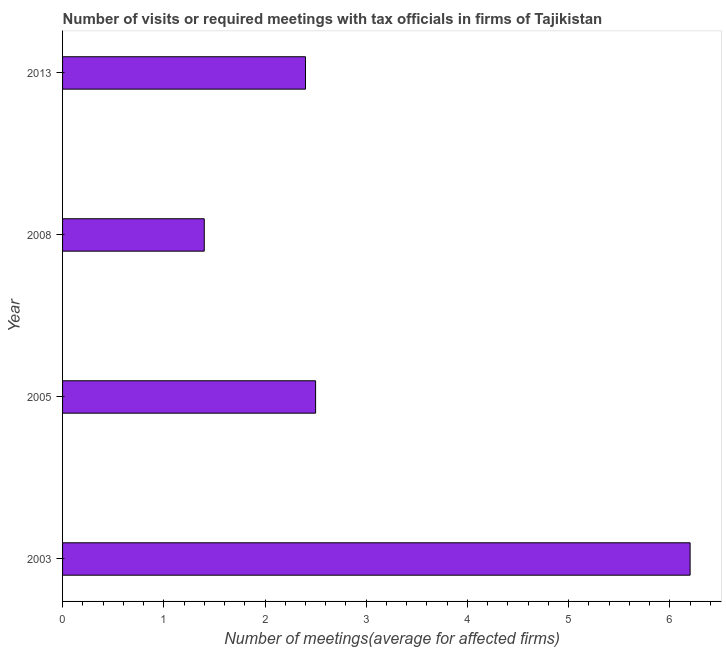Does the graph contain any zero values?
Offer a terse response. No. What is the title of the graph?
Your response must be concise. Number of visits or required meetings with tax officials in firms of Tajikistan. What is the label or title of the X-axis?
Ensure brevity in your answer.  Number of meetings(average for affected firms). What is the label or title of the Y-axis?
Your response must be concise. Year. What is the number of required meetings with tax officials in 2005?
Offer a terse response. 2.5. In which year was the number of required meetings with tax officials maximum?
Your answer should be very brief. 2003. In which year was the number of required meetings with tax officials minimum?
Your answer should be compact. 2008. What is the sum of the number of required meetings with tax officials?
Offer a terse response. 12.5. What is the difference between the number of required meetings with tax officials in 2005 and 2008?
Your answer should be compact. 1.1. What is the average number of required meetings with tax officials per year?
Give a very brief answer. 3.12. What is the median number of required meetings with tax officials?
Make the answer very short. 2.45. In how many years, is the number of required meetings with tax officials greater than 1.6 ?
Keep it short and to the point. 3. What is the ratio of the number of required meetings with tax officials in 2003 to that in 2005?
Your response must be concise. 2.48. Is the number of required meetings with tax officials in 2003 less than that in 2013?
Ensure brevity in your answer.  No. What is the difference between the highest and the second highest number of required meetings with tax officials?
Give a very brief answer. 3.7. In how many years, is the number of required meetings with tax officials greater than the average number of required meetings with tax officials taken over all years?
Offer a very short reply. 1. How many bars are there?
Your answer should be compact. 4. Are all the bars in the graph horizontal?
Keep it short and to the point. Yes. What is the difference between two consecutive major ticks on the X-axis?
Provide a short and direct response. 1. Are the values on the major ticks of X-axis written in scientific E-notation?
Offer a very short reply. No. What is the ratio of the Number of meetings(average for affected firms) in 2003 to that in 2005?
Offer a very short reply. 2.48. What is the ratio of the Number of meetings(average for affected firms) in 2003 to that in 2008?
Your answer should be very brief. 4.43. What is the ratio of the Number of meetings(average for affected firms) in 2003 to that in 2013?
Your response must be concise. 2.58. What is the ratio of the Number of meetings(average for affected firms) in 2005 to that in 2008?
Make the answer very short. 1.79. What is the ratio of the Number of meetings(average for affected firms) in 2005 to that in 2013?
Give a very brief answer. 1.04. What is the ratio of the Number of meetings(average for affected firms) in 2008 to that in 2013?
Offer a very short reply. 0.58. 